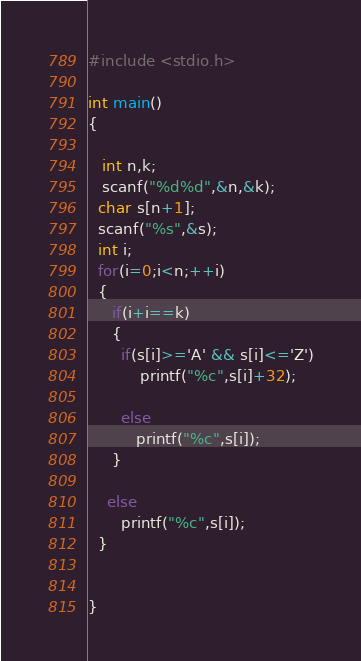Convert code to text. <code><loc_0><loc_0><loc_500><loc_500><_C_>#include <stdio.h>
 
int main()
{
 
   int n,k;
   scanf("%d%d",&n,&k);
  char s[n+1];
  scanf("%s",&s);
  int i;
  for(i=0;i<n;++i)
  {
     if(i+i==k)
     {
       if(s[i]>='A' && s[i]<='Z')
           printf("%c",s[i]+32);
       
       else
          printf("%c",s[i]);
     }
    
    else
       printf("%c",s[i]);
  }
  
  
}</code> 